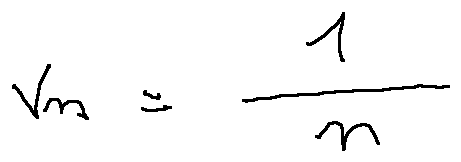Convert formula to latex. <formula><loc_0><loc_0><loc_500><loc_500>v _ { n } = \frac { 1 } { n }</formula> 